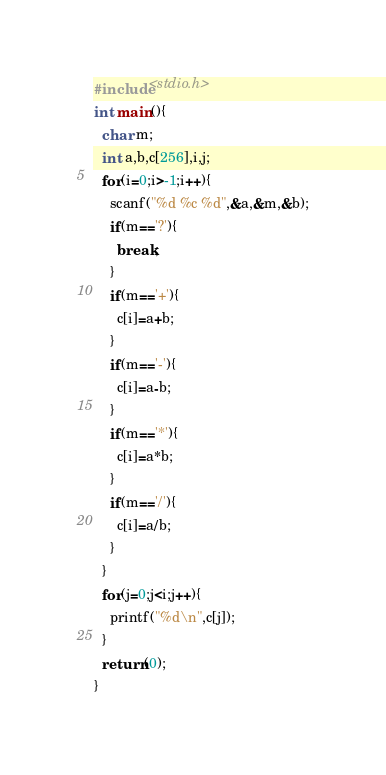Convert code to text. <code><loc_0><loc_0><loc_500><loc_500><_C_>#include<stdio.h>
int main(){
  char m;
  int a,b,c[256],i,j;
  for(i=0;i>-1;i++){
    scanf("%d %c %d",&a,&m,&b);
    if(m=='?'){
      break;
    }
    if(m=='+'){
      c[i]=a+b;
    }
    if(m=='-'){
      c[i]=a-b;
    }
    if(m=='*'){
      c[i]=a*b;
    }
    if(m=='/'){
      c[i]=a/b;
    }
  }
  for(j=0;j<i;j++){
    printf("%d\n",c[j]);
  }
  return(0);
}</code> 